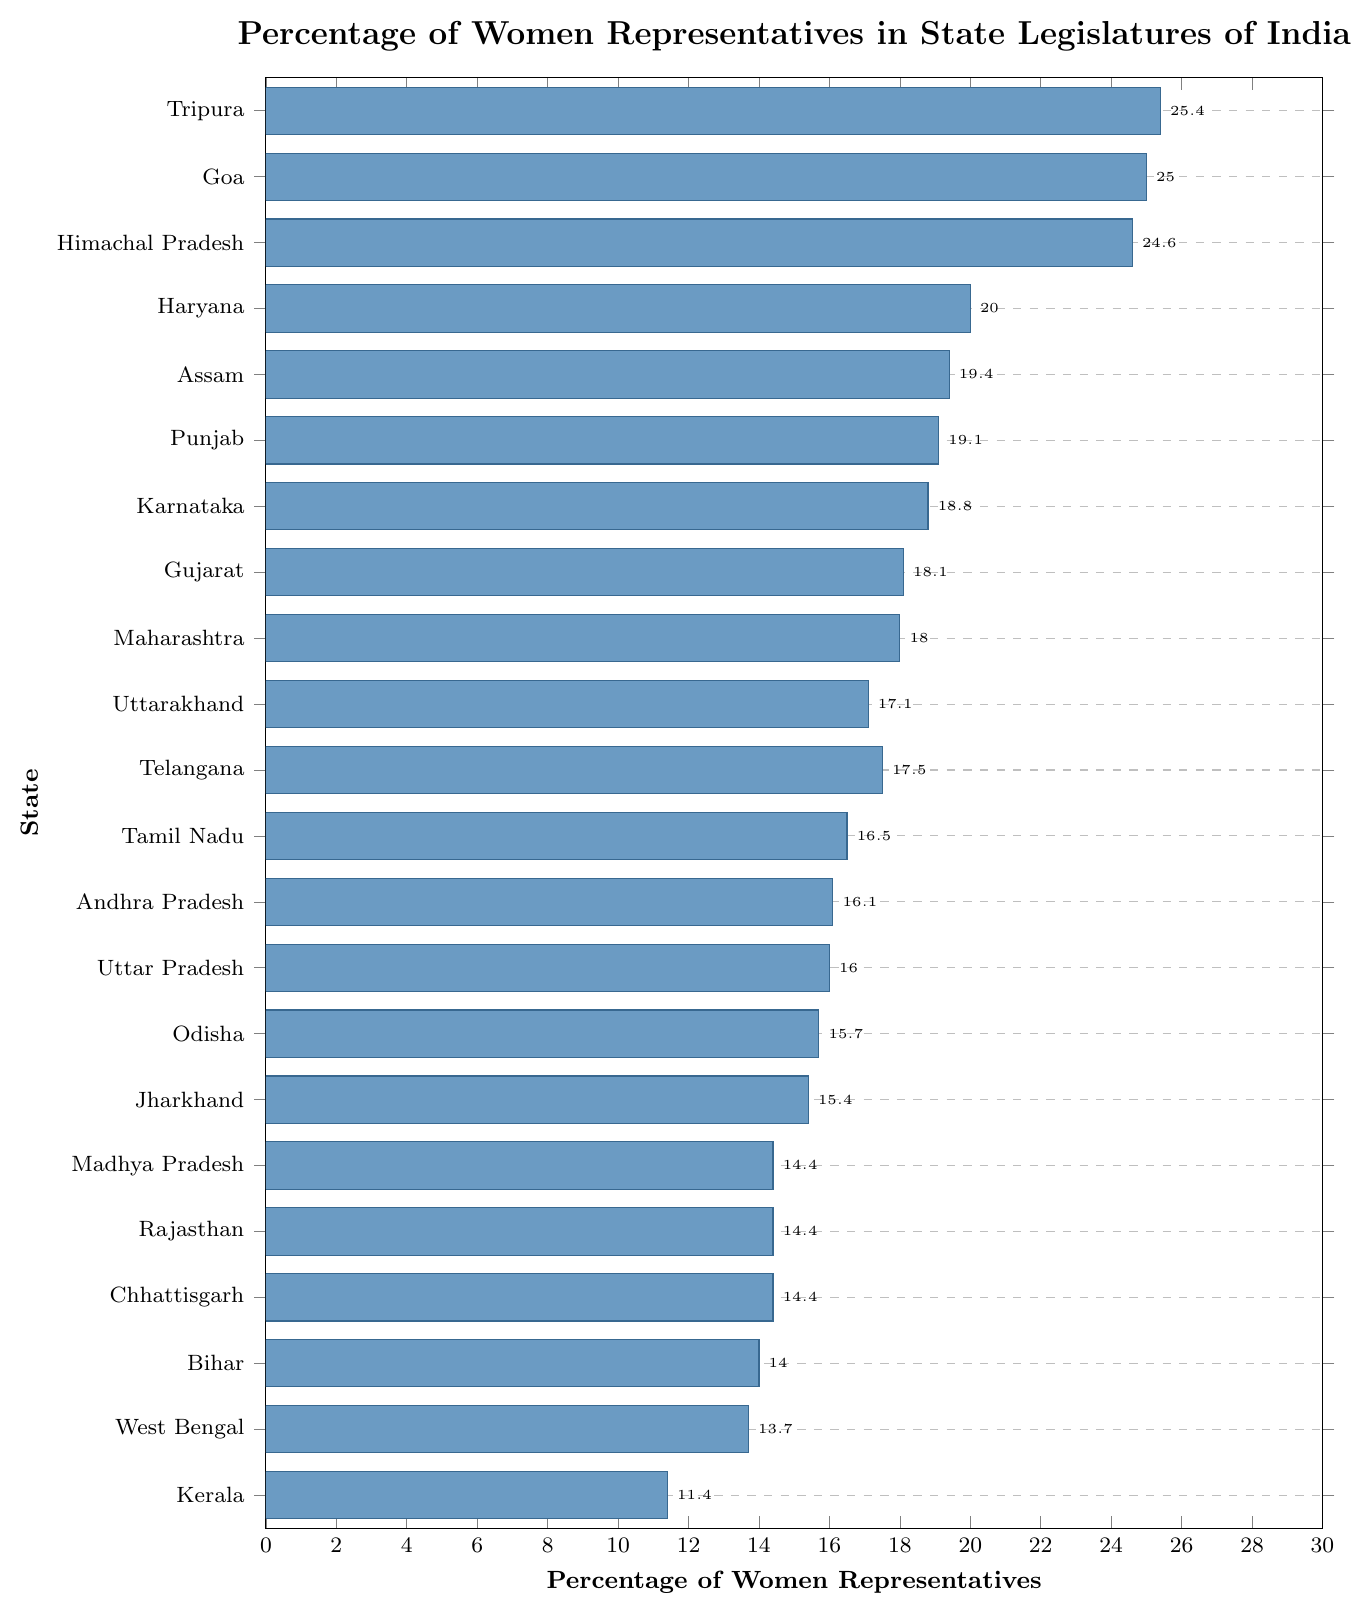Which state has the highest percentage of women representatives? The state with the highest percentage of women representatives can be found by locating the longest bar on the chart.
Answer: Tripura Which state has a higher percentage of women representatives: Tamil Nadu or Uttar Pradesh? Compare the lengths of the bars for Tamil Nadu and Uttar Pradesh. Tamil Nadu has a percentage of 16.5, while Uttar Pradesh has 16.0.
Answer: Tamil Nadu Which states have an equal percentage of 14.4% women representatives? Locate the bars with a percentage value of 14.4% and list the corresponding states.
Answer: Chhattisgarh, Rajasthan, Madhya Pradesh What is the difference in percentages of women representatives between Goa and Kerala? Subtract the percentage of Kerala from the percentage of Goa. 25.0 - 11.4 = 13.6.
Answer: 13.6 What is the sum of the percentages for Maharashtra, Gujarat, and Karnataka? Add the percentage values for Maharashtra (18.0), Gujarat (18.1), and Karnataka (18.8). 18.0 + 18.1 + 18.8 = 54.9.
Answer: 54.9 What is the average percentage of women representatives in Uttar Pradesh, Andhra Pradesh, and Telangana? Sum the percentage values for these three states and divide by 3. (16.0 + 16.1 + 17.5) / 3 = 16.53.
Answer: 16.53 Which state has the second highest percentage of women representatives? Identify the second longest bar on the chart. The state with the highest percentage is Tripura, followed by Goa.
Answer: Goa Is the percentage of women representatives in Punjab greater than in Jharkhand? Compare the percentages of the two states: Punjab has 19.1% and Jharkhand has 15.4%.
Answer: Yes How many states have a percentage of women representatives greater than 20%? Count the number of bars with percentage values greater than 20%. Tripura (25.4), Goa (25.0), Himachal Pradesh (24.6), Haryana (20.0), Assam (19.4), Punjab (19.1) - only these states are greater than 20%.
Answer: 4 What is the median percentage of women representatives for the data provided? Order the percentages in ascending order and find the middle value. The ordered percentages list is: 11.4, 13.7, 14.0, 14.4, 14.4, 14.4, 15.4, 15.7, 16.0, 16.1, 16.5, 17.1, 17.5, 18.0, 18.1, 18.8, 19.1, 19.4, 20.0, 24.6, 25.0, 25.4. The middle position is between the 11th and 12th values, which are 16.5 and 17.1. The median is (16.5 + 17.1) / 2 = 16.8.
Answer: 16.8 